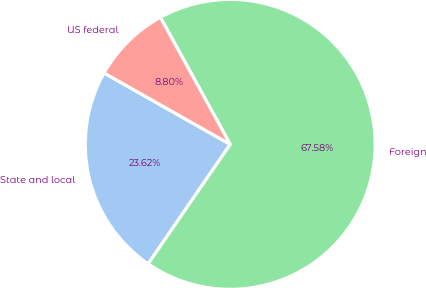Convert chart to OTSL. <chart><loc_0><loc_0><loc_500><loc_500><pie_chart><fcel>State and local<fcel>Foreign<fcel>US federal<nl><fcel>23.62%<fcel>67.58%<fcel>8.8%<nl></chart> 